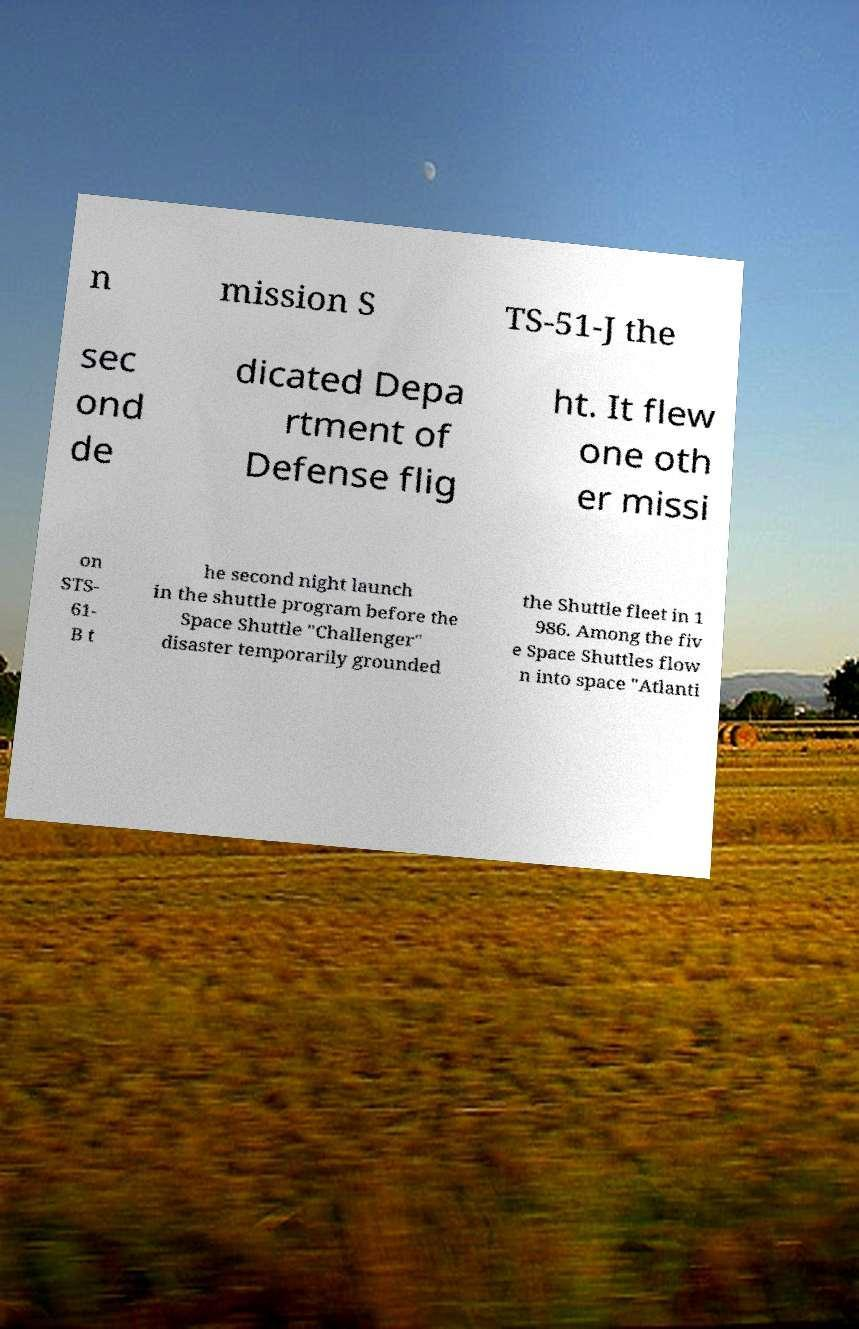There's text embedded in this image that I need extracted. Can you transcribe it verbatim? n mission S TS-51-J the sec ond de dicated Depa rtment of Defense flig ht. It flew one oth er missi on STS- 61- B t he second night launch in the shuttle program before the Space Shuttle "Challenger" disaster temporarily grounded the Shuttle fleet in 1 986. Among the fiv e Space Shuttles flow n into space "Atlanti 